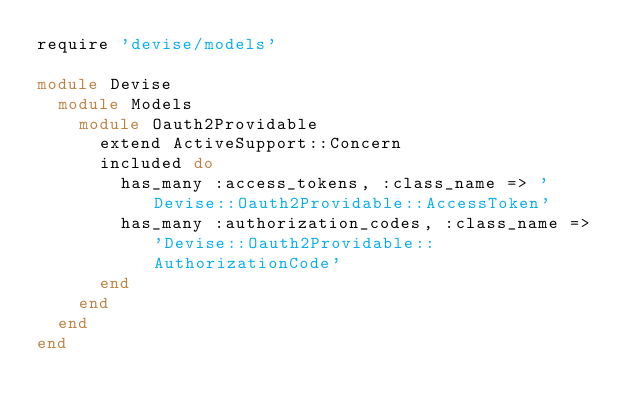Convert code to text. <code><loc_0><loc_0><loc_500><loc_500><_Ruby_>require 'devise/models'

module Devise
  module Models
    module Oauth2Providable
      extend ActiveSupport::Concern
      included do
        has_many :access_tokens, :class_name => 'Devise::Oauth2Providable::AccessToken'
        has_many :authorization_codes, :class_name => 'Devise::Oauth2Providable::AuthorizationCode'
      end
    end
  end
end
</code> 